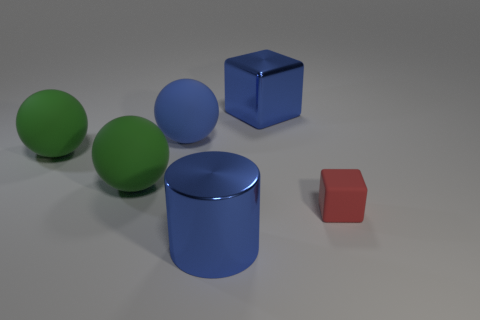Is there any other thing that has the same material as the large blue cube?
Your answer should be compact. Yes. What number of objects are rubber things or blue things in front of the blue sphere?
Your answer should be very brief. 5. Is the size of the blue cylinder that is in front of the red rubber object the same as the blue shiny cube?
Your answer should be very brief. Yes. What number of other things are the same shape as the big blue matte object?
Provide a short and direct response. 2. What number of brown things are either matte spheres or blocks?
Ensure brevity in your answer.  0. There is a cube behind the small rubber thing; is its color the same as the tiny matte object?
Offer a very short reply. No. There is a big blue object that is made of the same material as the big block; what shape is it?
Keep it short and to the point. Cylinder. The object that is both behind the small red rubber block and on the right side of the cylinder is what color?
Provide a short and direct response. Blue. What is the size of the matte thing right of the shiny thing to the left of the metal cube?
Make the answer very short. Small. Are there any tiny matte cubes of the same color as the small rubber object?
Offer a terse response. No. 